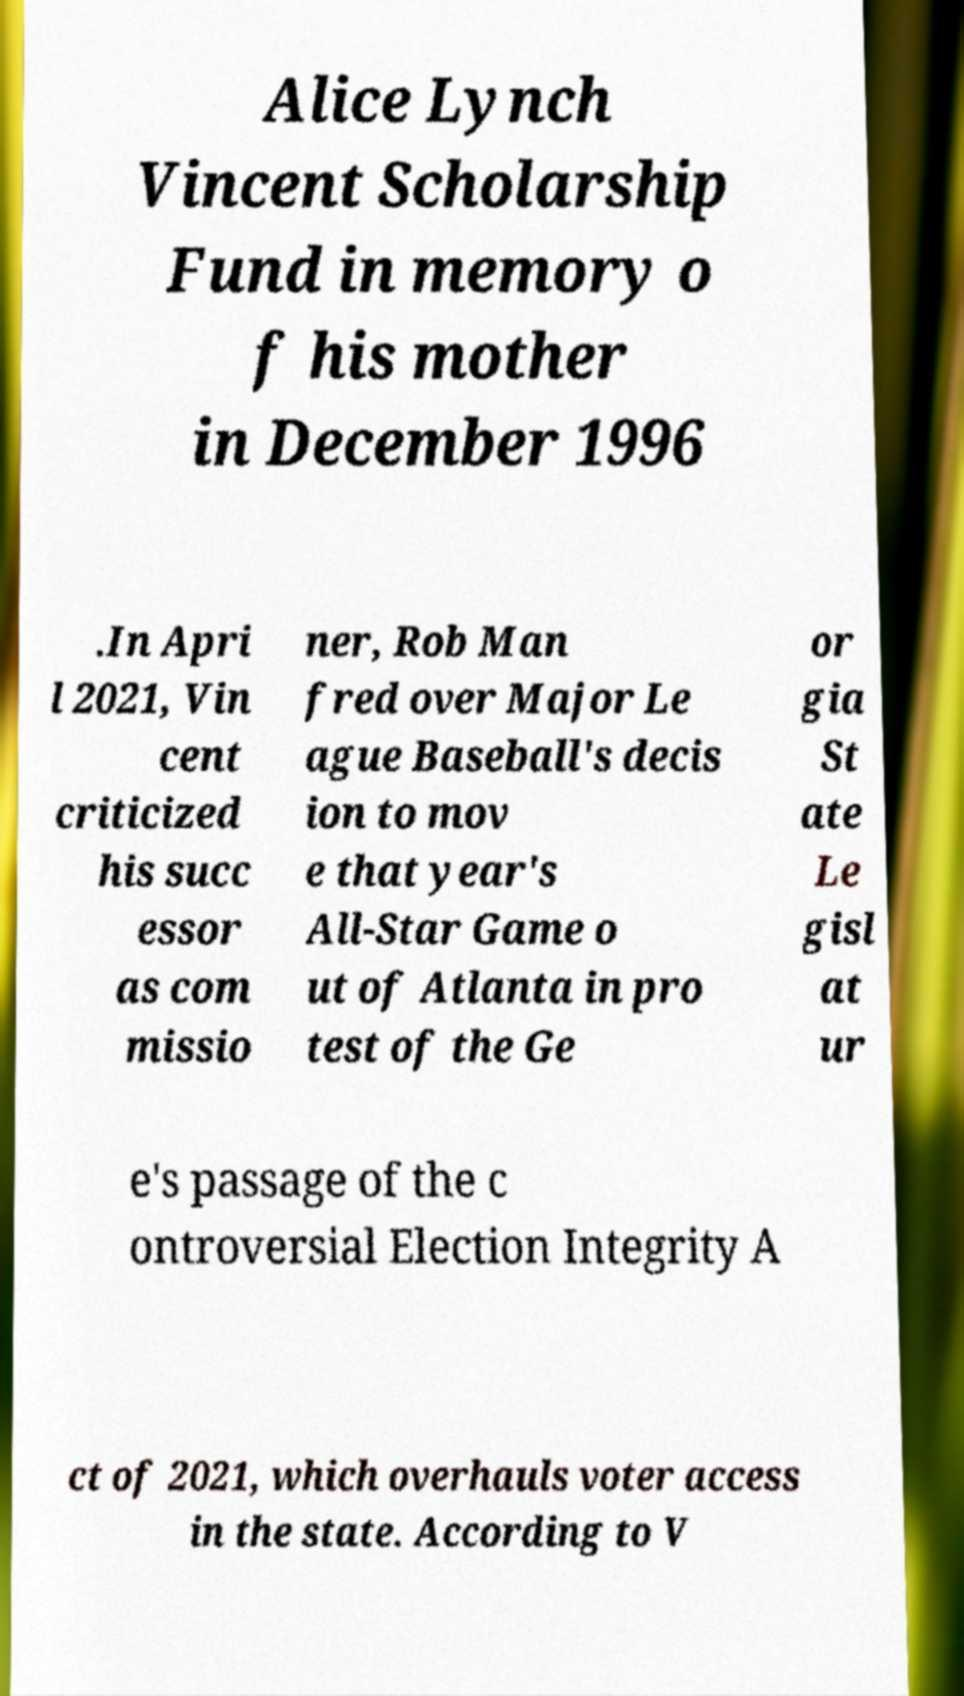I need the written content from this picture converted into text. Can you do that? Alice Lynch Vincent Scholarship Fund in memory o f his mother in December 1996 .In Apri l 2021, Vin cent criticized his succ essor as com missio ner, Rob Man fred over Major Le ague Baseball's decis ion to mov e that year's All-Star Game o ut of Atlanta in pro test of the Ge or gia St ate Le gisl at ur e's passage of the c ontroversial Election Integrity A ct of 2021, which overhauls voter access in the state. According to V 